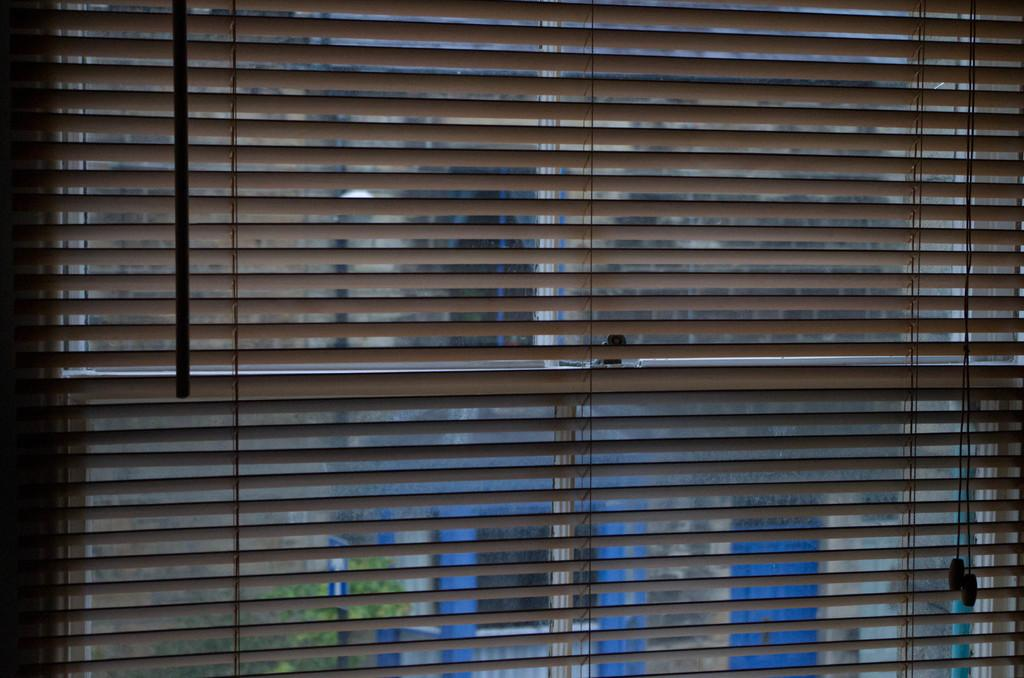What is located near the window in the image? There is a window blind near the window in the image. What can be seen through the window? A tree and another building are visible through the window. What type of channel can be seen running through the image? There is no channel visible in the image. 